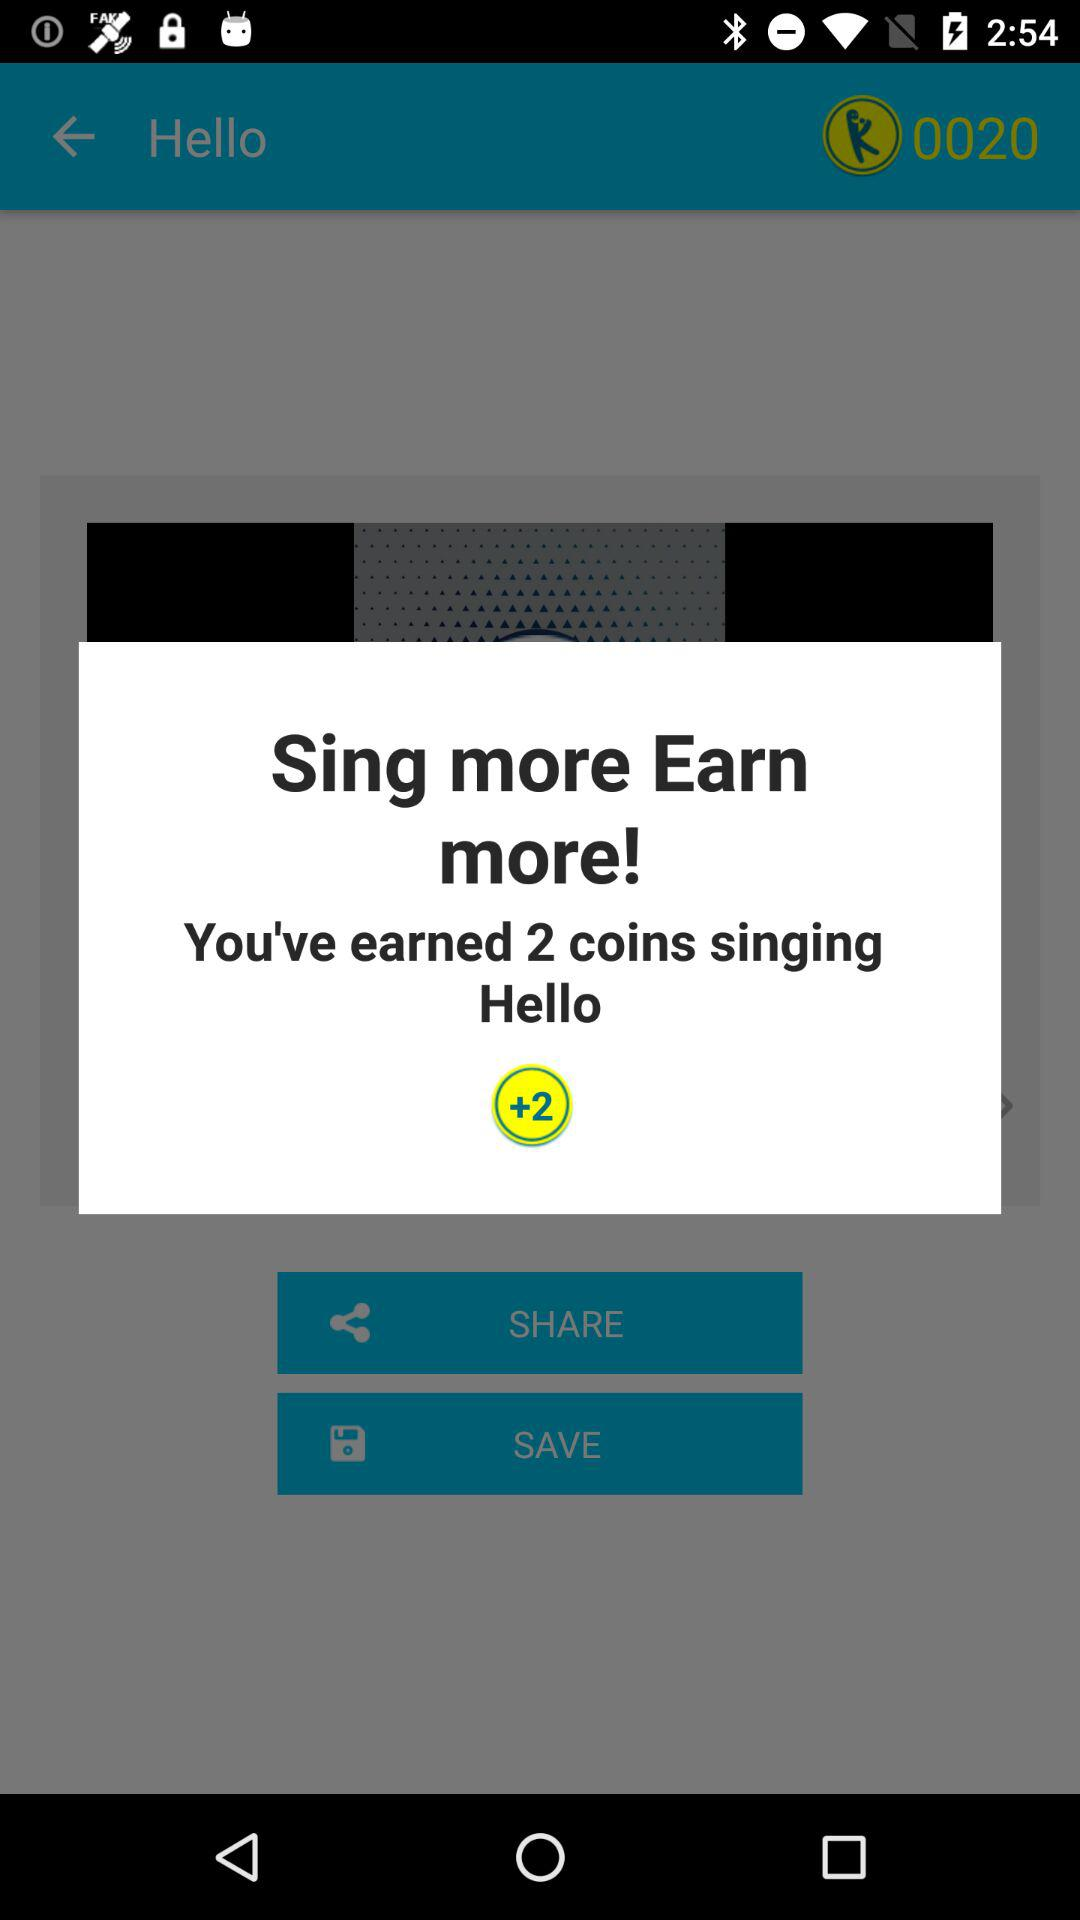How many coins have been earned by singing "Hello"? By singing "Hello", 2 coins have been earned. 